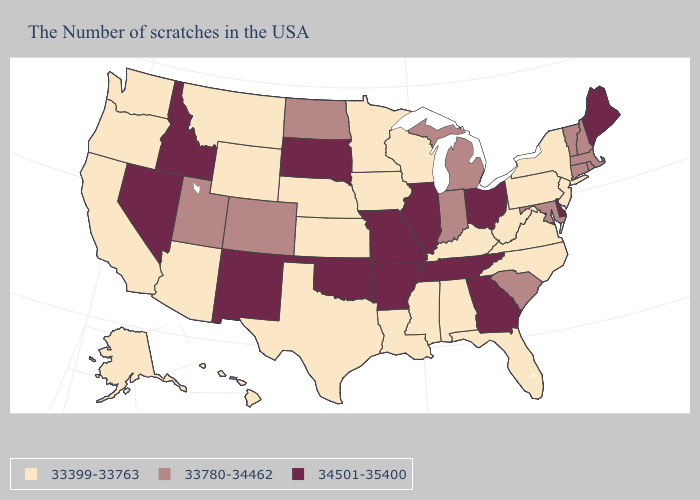How many symbols are there in the legend?
Answer briefly. 3. Among the states that border Connecticut , does New York have the highest value?
Concise answer only. No. Among the states that border Mississippi , which have the lowest value?
Concise answer only. Alabama, Louisiana. Is the legend a continuous bar?
Give a very brief answer. No. Does the map have missing data?
Give a very brief answer. No. Does Ohio have the same value as North Dakota?
Write a very short answer. No. Does New Mexico have the highest value in the West?
Write a very short answer. Yes. Does Virginia have the lowest value in the USA?
Answer briefly. Yes. What is the value of Virginia?
Quick response, please. 33399-33763. Does Minnesota have a lower value than North Dakota?
Short answer required. Yes. Name the states that have a value in the range 34501-35400?
Quick response, please. Maine, Delaware, Ohio, Georgia, Tennessee, Illinois, Missouri, Arkansas, Oklahoma, South Dakota, New Mexico, Idaho, Nevada. What is the value of Oregon?
Give a very brief answer. 33399-33763. What is the value of Rhode Island?
Keep it brief. 33780-34462. Which states have the highest value in the USA?
Concise answer only. Maine, Delaware, Ohio, Georgia, Tennessee, Illinois, Missouri, Arkansas, Oklahoma, South Dakota, New Mexico, Idaho, Nevada. What is the value of North Carolina?
Quick response, please. 33399-33763. 